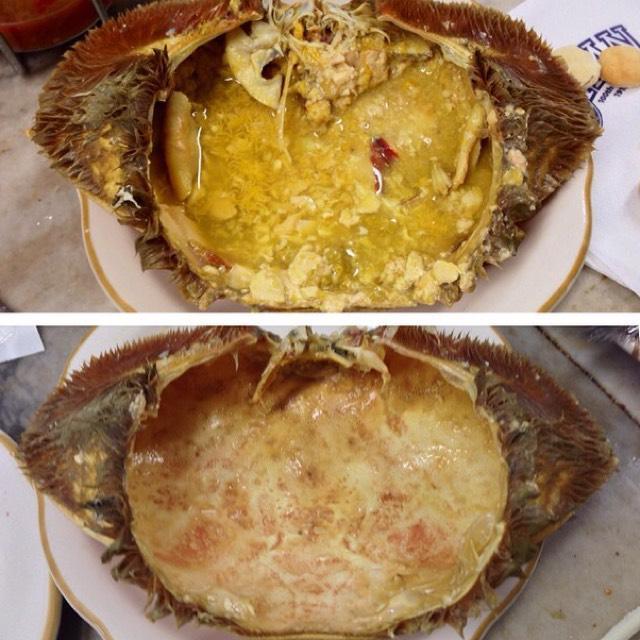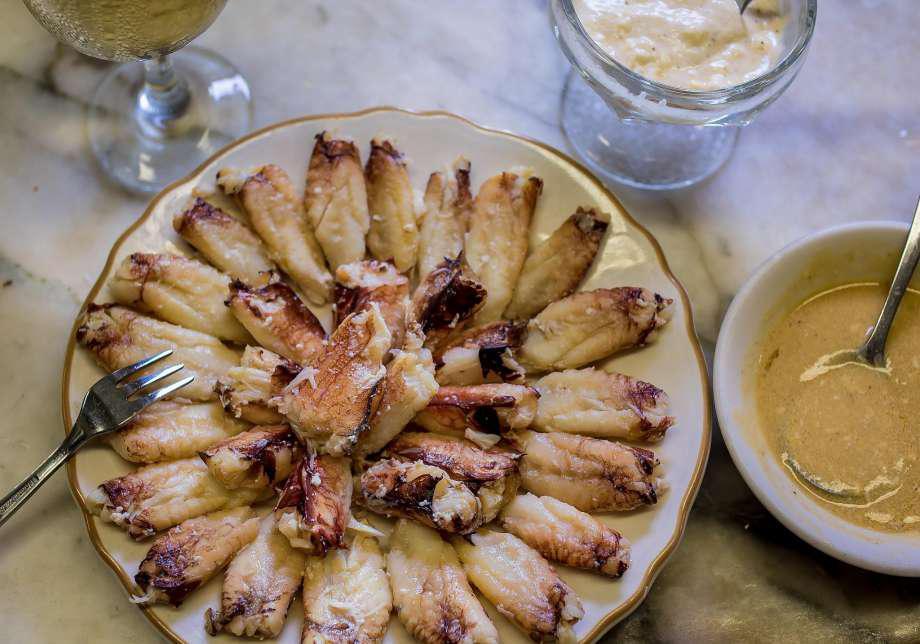The first image is the image on the left, the second image is the image on the right. Given the left and right images, does the statement "In the image on the left, there is a dish containing only crab legs." hold true? Answer yes or no. No. The first image is the image on the left, the second image is the image on the right. Examine the images to the left and right. Is the description "The left image shows a hollowed-out crab shell on a gold-rimmed plate with yellowish broth inside." accurate? Answer yes or no. Yes. 